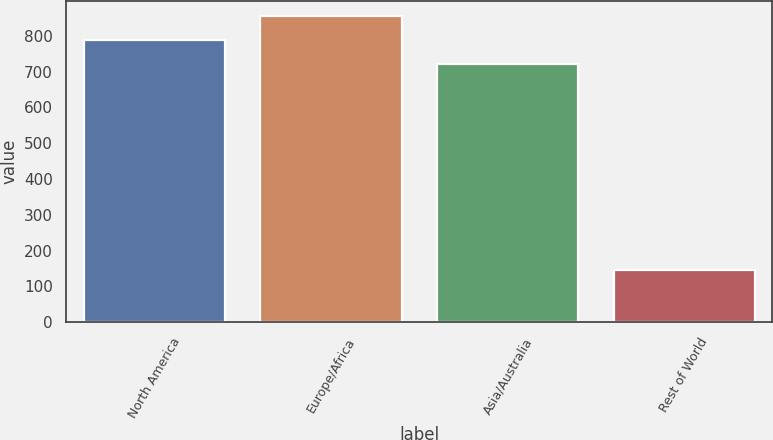<chart> <loc_0><loc_0><loc_500><loc_500><bar_chart><fcel>North America<fcel>Europe/Africa<fcel>Asia/Australia<fcel>Rest of World<nl><fcel>788.4<fcel>854.8<fcel>722<fcel>147<nl></chart> 